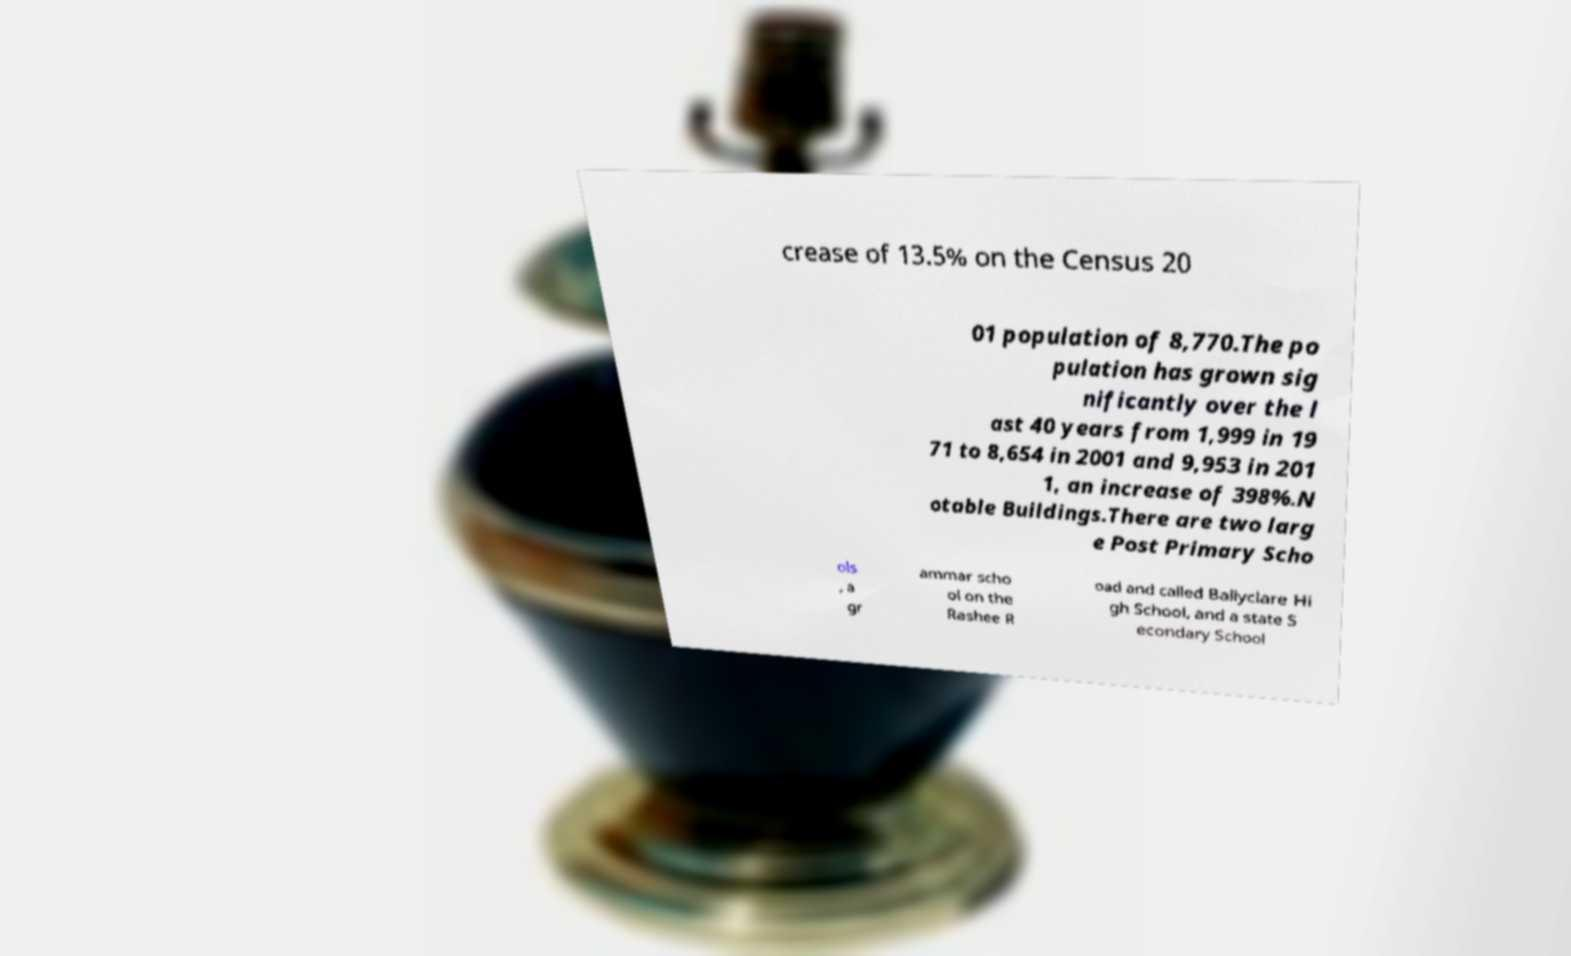There's text embedded in this image that I need extracted. Can you transcribe it verbatim? crease of 13.5% on the Census 20 01 population of 8,770.The po pulation has grown sig nificantly over the l ast 40 years from 1,999 in 19 71 to 8,654 in 2001 and 9,953 in 201 1, an increase of 398%.N otable Buildings.There are two larg e Post Primary Scho ols , a gr ammar scho ol on the Rashee R oad and called Ballyclare Hi gh School, and a state S econdary School 